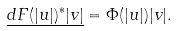Convert formula to latex. <formula><loc_0><loc_0><loc_500><loc_500>\underline { d F ( | u | ) ^ { * } | v | } = \Phi ( | u | ) | v | .</formula> 